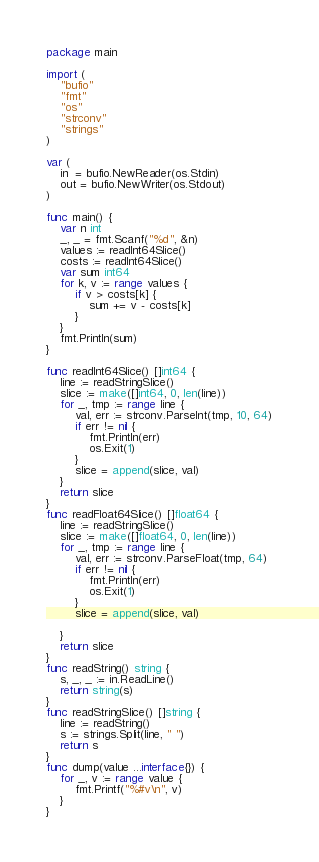<code> <loc_0><loc_0><loc_500><loc_500><_Go_>package main

import (
	"bufio"
	"fmt"
	"os"
	"strconv"
	"strings"
)

var (
	in  = bufio.NewReader(os.Stdin)
	out = bufio.NewWriter(os.Stdout)
)

func main() {
	var n int
	_, _ = fmt.Scanf("%d", &n)
	values := readInt64Slice()
	costs := readInt64Slice()
	var sum int64
	for k, v := range values {
		if v > costs[k] {
			sum += v - costs[k]
		}
	}
	fmt.Println(sum)
}

func readInt64Slice() []int64 {
	line := readStringSlice()
	slice := make([]int64, 0, len(line))
	for _, tmp := range line {
		val, err := strconv.ParseInt(tmp, 10, 64)
		if err != nil {
			fmt.Println(err)
			os.Exit(1)
		}
		slice = append(slice, val)
	}
	return slice
}
func readFloat64Slice() []float64 {
	line := readStringSlice()
	slice := make([]float64, 0, len(line))
	for _, tmp := range line {
		val, err := strconv.ParseFloat(tmp, 64)
		if err != nil {
			fmt.Println(err)
			os.Exit(1)
		}
		slice = append(slice, val)

	}
	return slice
}
func readString() string {
	s, _, _ := in.ReadLine()
	return string(s)
}
func readStringSlice() []string {
	line := readString()
	s := strings.Split(line, " ")
	return s
}
func dump(value ...interface{}) {
	for _, v := range value {
		fmt.Printf("%#v\n", v)
	}
}
</code> 